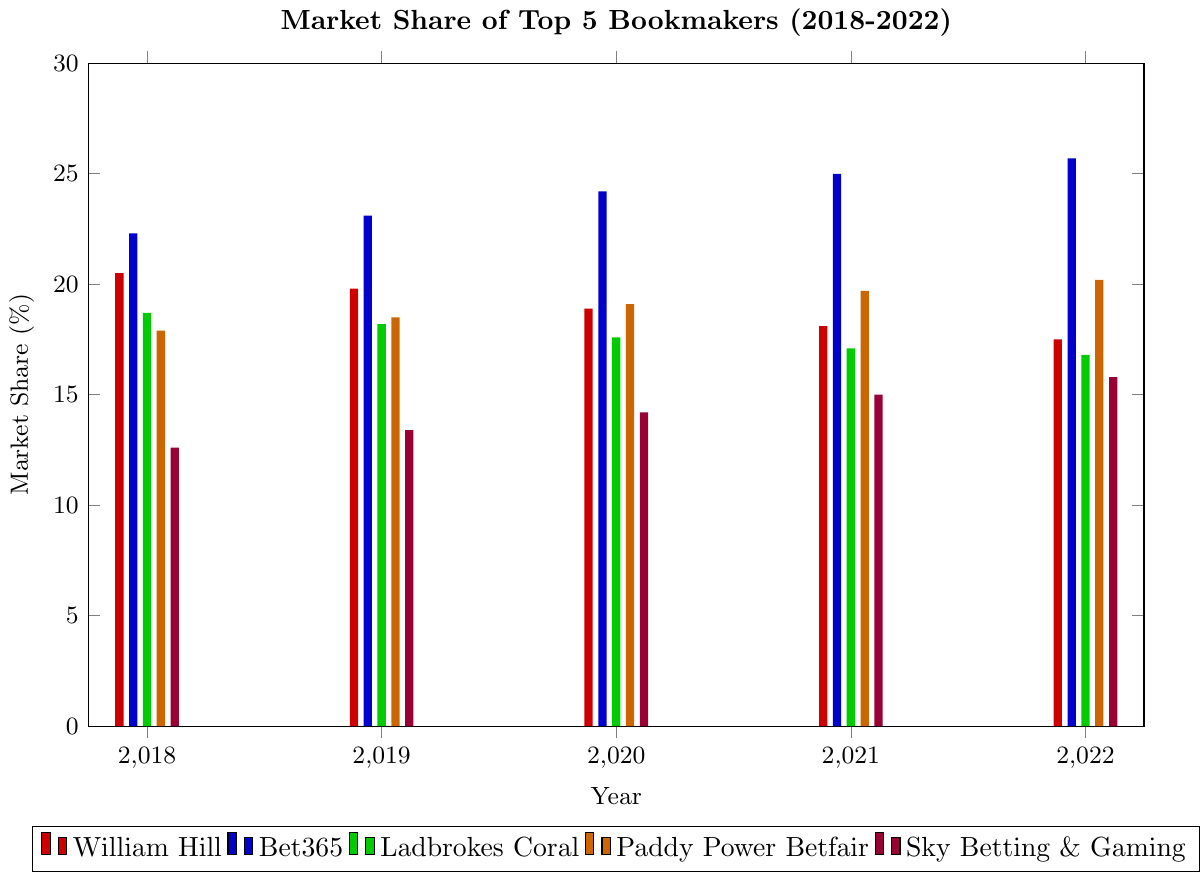What is the trend in market share for William Hill over the 5-year period? To determine the trend, we observe the market share of William Hill from 2018 to 2022: decreasing from 20.5% in 2018 to 17.5% in 2022. This indicates a declining trend.
Answer: Declining Between Bet365 and Ladbrokes Coral, which bookmaker had the higher market share in 2020? Compare the 2020 market shares: Bet365 (24.2%), Ladbrokes Coral (17.6%). Bet365 had a higher market share.
Answer: Bet365 Which bookmaker experienced the largest increase in market share from 2018 to 2022? Calculate the change: Bet365 (25.7 - 22.3 = 3.4), Paddy Power Betfair (20.2 - 17.9 = 2.3), Sky Betting & Gaming (15.8 - 12.6 = 3.2), William Hill (17.5 - 20.5 = -3), Ladbrokes Coral (16.8 - 18.7 = -1.9). Bet365 experienced the largest increase.
Answer: Bet365 What is the sum of the market shares of Paddy Power Betfair and Sky Betting & Gaming in 2022? Sum of market shares in 2022: Paddy Power Betfair (20.2) + Sky Betting & Gaming (15.8) = 36.0.
Answer: 36.0 How does the market share of Bet365 in 2019 compare to its market share in 2021? Compare the market shares: 2019 (23.1%), 2021 (25.0%). Bet365's market share increased from 2019 to 2021.
Answer: Increased Which bookmaker had the smallest decrease in market share from 2018 to 2022? Calculate decreases: William Hill (20.5 - 17.5 = 3.0), Ladbrokes Coral (18.7 - 16.8 = 1.9). Ladbrokes Coral experienced the smallest decrease.
Answer: Ladbrokes Coral What is the average market share of Sky Betting & Gaming over the 5-year period? Sum the market shares over 5 years: (12.6 + 13.4 + 14.2 + 15.0 + 15.8) = 71.0. Divide by 5: 71.0 / 5 = 14.2.
Answer: 14.2 Which bookmaker had the highest market share in 2022? Look at the 2022 market shares: William Hill (17.5%), Bet365 (25.7%), Ladbrokes Coral (16.8%), Paddy Power Betfair (20.2%), Sky Betting & Gaming (15.8%). Bet365 had the highest market share.
Answer: Bet365 Compare the market share trends of William Hill and Paddy Power Betfair. William Hill's market share decreased from 20.5% (2018) to 17.5% (2022), while Paddy Power Betfair's increased from 17.9% (2018) to 20.2% (2022). William Hill has a declining trend, and Paddy Power Betfair has an increasing trend.
Answer: William Hill declining, Paddy Power Betfair increasing If the total market share in 2022 is 96%, what percentage does the rest of the market (outside the top 5) hold? Sum market shares of the top 5 in 2022: 17.5 (William Hill) + 25.7 (Bet365) + 16.8 (Ladbrokes Coral) + 20.2 (Paddy Power Betfair) + 15.8 (Sky Betting & Gaming) = 96. The rest of the market holds 100 - 96 = 4%.
Answer: 4% 